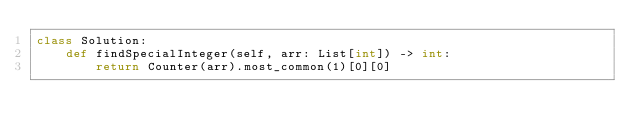Convert code to text. <code><loc_0><loc_0><loc_500><loc_500><_Python_>class Solution:
    def findSpecialInteger(self, arr: List[int]) -> int:
        return Counter(arr).most_common(1)[0][0]
</code> 